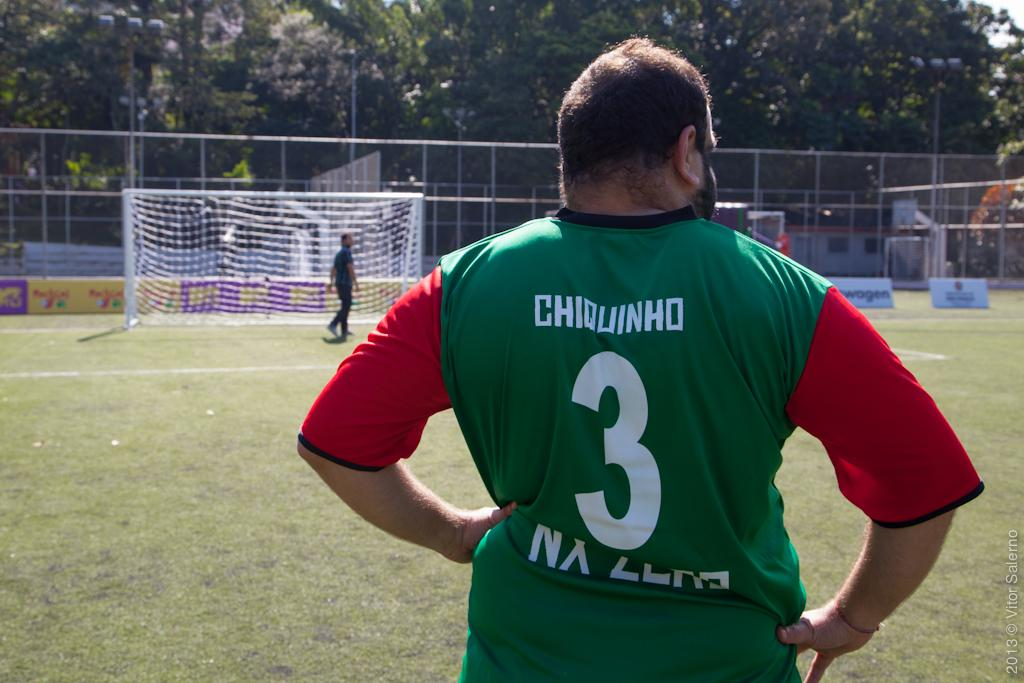<image>
Present a compact description of the photo's key features. a man wears the shirt with the number 3 on it 